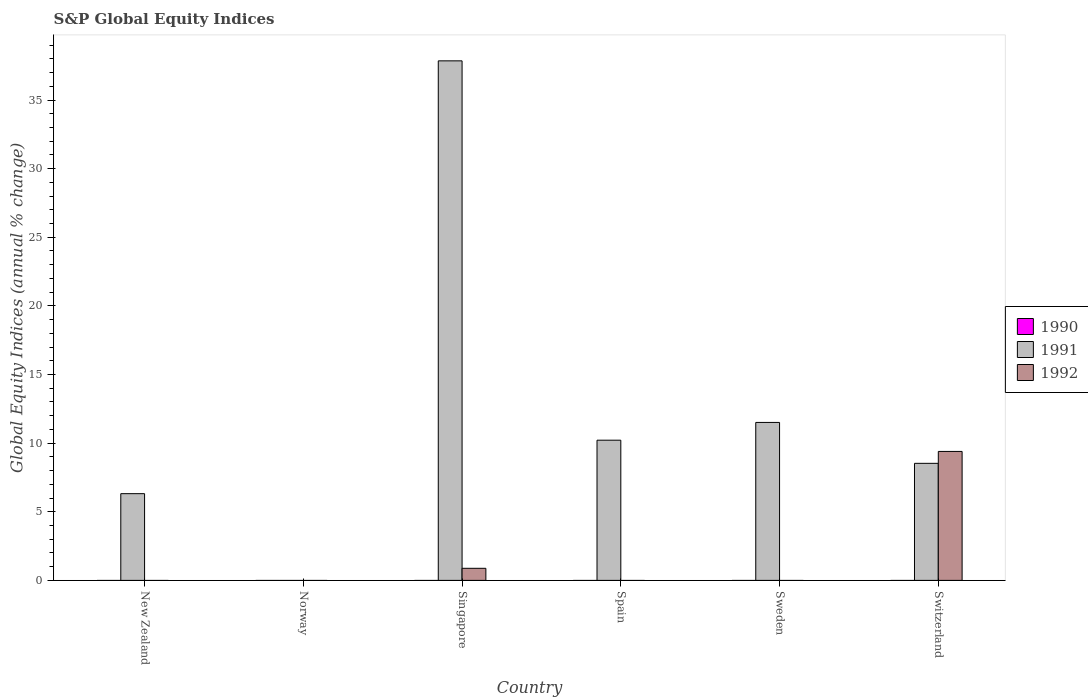How many different coloured bars are there?
Your answer should be very brief. 2. Are the number of bars per tick equal to the number of legend labels?
Offer a terse response. No. How many bars are there on the 1st tick from the left?
Ensure brevity in your answer.  1. How many bars are there on the 1st tick from the right?
Your answer should be very brief. 2. In how many cases, is the number of bars for a given country not equal to the number of legend labels?
Your answer should be very brief. 6. What is the global equity indices in 1991 in Singapore?
Provide a succinct answer. 37.85. Across all countries, what is the maximum global equity indices in 1992?
Give a very brief answer. 9.4. Across all countries, what is the minimum global equity indices in 1991?
Offer a very short reply. 0. In which country was the global equity indices in 1991 maximum?
Ensure brevity in your answer.  Singapore. What is the total global equity indices in 1991 in the graph?
Your response must be concise. 74.42. What is the difference between the global equity indices in 1991 in Spain and that in Switzerland?
Make the answer very short. 1.69. What is the difference between the global equity indices in 1992 in Spain and the global equity indices in 1991 in New Zealand?
Keep it short and to the point. -6.32. What is the average global equity indices in 1992 per country?
Offer a very short reply. 1.71. What is the ratio of the global equity indices in 1991 in Singapore to that in Sweden?
Offer a terse response. 3.29. Is the global equity indices in 1991 in Singapore less than that in Spain?
Offer a terse response. No. What is the difference between the highest and the second highest global equity indices in 1991?
Provide a short and direct response. -1.29. What is the difference between the highest and the lowest global equity indices in 1992?
Keep it short and to the point. 9.4. In how many countries, is the global equity indices in 1992 greater than the average global equity indices in 1992 taken over all countries?
Keep it short and to the point. 1. Is the sum of the global equity indices in 1992 in Singapore and Switzerland greater than the maximum global equity indices in 1990 across all countries?
Provide a short and direct response. Yes. Is it the case that in every country, the sum of the global equity indices in 1990 and global equity indices in 1992 is greater than the global equity indices in 1991?
Your answer should be compact. No. Are all the bars in the graph horizontal?
Provide a succinct answer. No. How many countries are there in the graph?
Keep it short and to the point. 6. Does the graph contain any zero values?
Offer a very short reply. Yes. Does the graph contain grids?
Your answer should be very brief. No. Where does the legend appear in the graph?
Keep it short and to the point. Center right. How many legend labels are there?
Your answer should be very brief. 3. How are the legend labels stacked?
Your answer should be compact. Vertical. What is the title of the graph?
Your answer should be very brief. S&P Global Equity Indices. Does "1969" appear as one of the legend labels in the graph?
Provide a succinct answer. No. What is the label or title of the Y-axis?
Ensure brevity in your answer.  Global Equity Indices (annual % change). What is the Global Equity Indices (annual % change) in 1990 in New Zealand?
Your answer should be very brief. 0. What is the Global Equity Indices (annual % change) of 1991 in New Zealand?
Offer a very short reply. 6.32. What is the Global Equity Indices (annual % change) in 1992 in New Zealand?
Ensure brevity in your answer.  0. What is the Global Equity Indices (annual % change) of 1990 in Norway?
Your answer should be compact. 0. What is the Global Equity Indices (annual % change) in 1990 in Singapore?
Provide a short and direct response. 0. What is the Global Equity Indices (annual % change) of 1991 in Singapore?
Offer a terse response. 37.85. What is the Global Equity Indices (annual % change) in 1992 in Singapore?
Provide a succinct answer. 0.88. What is the Global Equity Indices (annual % change) in 1990 in Spain?
Your answer should be very brief. 0. What is the Global Equity Indices (annual % change) of 1991 in Spain?
Offer a very short reply. 10.21. What is the Global Equity Indices (annual % change) in 1992 in Spain?
Your response must be concise. 0. What is the Global Equity Indices (annual % change) of 1991 in Sweden?
Provide a short and direct response. 11.51. What is the Global Equity Indices (annual % change) of 1990 in Switzerland?
Keep it short and to the point. 0. What is the Global Equity Indices (annual % change) of 1991 in Switzerland?
Give a very brief answer. 8.53. What is the Global Equity Indices (annual % change) of 1992 in Switzerland?
Give a very brief answer. 9.4. Across all countries, what is the maximum Global Equity Indices (annual % change) in 1991?
Your answer should be very brief. 37.85. Across all countries, what is the maximum Global Equity Indices (annual % change) in 1992?
Keep it short and to the point. 9.4. Across all countries, what is the minimum Global Equity Indices (annual % change) of 1991?
Keep it short and to the point. 0. Across all countries, what is the minimum Global Equity Indices (annual % change) in 1992?
Ensure brevity in your answer.  0. What is the total Global Equity Indices (annual % change) of 1991 in the graph?
Give a very brief answer. 74.42. What is the total Global Equity Indices (annual % change) of 1992 in the graph?
Keep it short and to the point. 10.28. What is the difference between the Global Equity Indices (annual % change) in 1991 in New Zealand and that in Singapore?
Make the answer very short. -31.53. What is the difference between the Global Equity Indices (annual % change) of 1991 in New Zealand and that in Spain?
Your answer should be compact. -3.9. What is the difference between the Global Equity Indices (annual % change) of 1991 in New Zealand and that in Sweden?
Offer a very short reply. -5.19. What is the difference between the Global Equity Indices (annual % change) of 1991 in New Zealand and that in Switzerland?
Make the answer very short. -2.21. What is the difference between the Global Equity Indices (annual % change) in 1991 in Singapore and that in Spain?
Your answer should be very brief. 27.64. What is the difference between the Global Equity Indices (annual % change) in 1991 in Singapore and that in Sweden?
Make the answer very short. 26.34. What is the difference between the Global Equity Indices (annual % change) in 1991 in Singapore and that in Switzerland?
Your response must be concise. 29.32. What is the difference between the Global Equity Indices (annual % change) of 1992 in Singapore and that in Switzerland?
Provide a short and direct response. -8.51. What is the difference between the Global Equity Indices (annual % change) in 1991 in Spain and that in Sweden?
Offer a very short reply. -1.29. What is the difference between the Global Equity Indices (annual % change) of 1991 in Spain and that in Switzerland?
Your response must be concise. 1.69. What is the difference between the Global Equity Indices (annual % change) of 1991 in Sweden and that in Switzerland?
Your answer should be compact. 2.98. What is the difference between the Global Equity Indices (annual % change) in 1991 in New Zealand and the Global Equity Indices (annual % change) in 1992 in Singapore?
Give a very brief answer. 5.44. What is the difference between the Global Equity Indices (annual % change) in 1991 in New Zealand and the Global Equity Indices (annual % change) in 1992 in Switzerland?
Provide a short and direct response. -3.08. What is the difference between the Global Equity Indices (annual % change) of 1991 in Singapore and the Global Equity Indices (annual % change) of 1992 in Switzerland?
Offer a terse response. 28.46. What is the difference between the Global Equity Indices (annual % change) of 1991 in Spain and the Global Equity Indices (annual % change) of 1992 in Switzerland?
Provide a succinct answer. 0.82. What is the difference between the Global Equity Indices (annual % change) of 1991 in Sweden and the Global Equity Indices (annual % change) of 1992 in Switzerland?
Give a very brief answer. 2.11. What is the average Global Equity Indices (annual % change) in 1990 per country?
Offer a terse response. 0. What is the average Global Equity Indices (annual % change) of 1991 per country?
Make the answer very short. 12.4. What is the average Global Equity Indices (annual % change) of 1992 per country?
Ensure brevity in your answer.  1.71. What is the difference between the Global Equity Indices (annual % change) of 1991 and Global Equity Indices (annual % change) of 1992 in Singapore?
Give a very brief answer. 36.97. What is the difference between the Global Equity Indices (annual % change) in 1991 and Global Equity Indices (annual % change) in 1992 in Switzerland?
Keep it short and to the point. -0.87. What is the ratio of the Global Equity Indices (annual % change) in 1991 in New Zealand to that in Singapore?
Keep it short and to the point. 0.17. What is the ratio of the Global Equity Indices (annual % change) of 1991 in New Zealand to that in Spain?
Your answer should be compact. 0.62. What is the ratio of the Global Equity Indices (annual % change) of 1991 in New Zealand to that in Sweden?
Make the answer very short. 0.55. What is the ratio of the Global Equity Indices (annual % change) in 1991 in New Zealand to that in Switzerland?
Keep it short and to the point. 0.74. What is the ratio of the Global Equity Indices (annual % change) of 1991 in Singapore to that in Spain?
Your response must be concise. 3.71. What is the ratio of the Global Equity Indices (annual % change) in 1991 in Singapore to that in Sweden?
Provide a short and direct response. 3.29. What is the ratio of the Global Equity Indices (annual % change) of 1991 in Singapore to that in Switzerland?
Provide a succinct answer. 4.44. What is the ratio of the Global Equity Indices (annual % change) of 1992 in Singapore to that in Switzerland?
Your answer should be compact. 0.09. What is the ratio of the Global Equity Indices (annual % change) in 1991 in Spain to that in Sweden?
Ensure brevity in your answer.  0.89. What is the ratio of the Global Equity Indices (annual % change) in 1991 in Spain to that in Switzerland?
Keep it short and to the point. 1.2. What is the ratio of the Global Equity Indices (annual % change) of 1991 in Sweden to that in Switzerland?
Offer a very short reply. 1.35. What is the difference between the highest and the second highest Global Equity Indices (annual % change) of 1991?
Offer a terse response. 26.34. What is the difference between the highest and the lowest Global Equity Indices (annual % change) in 1991?
Offer a very short reply. 37.85. What is the difference between the highest and the lowest Global Equity Indices (annual % change) of 1992?
Your answer should be compact. 9.4. 